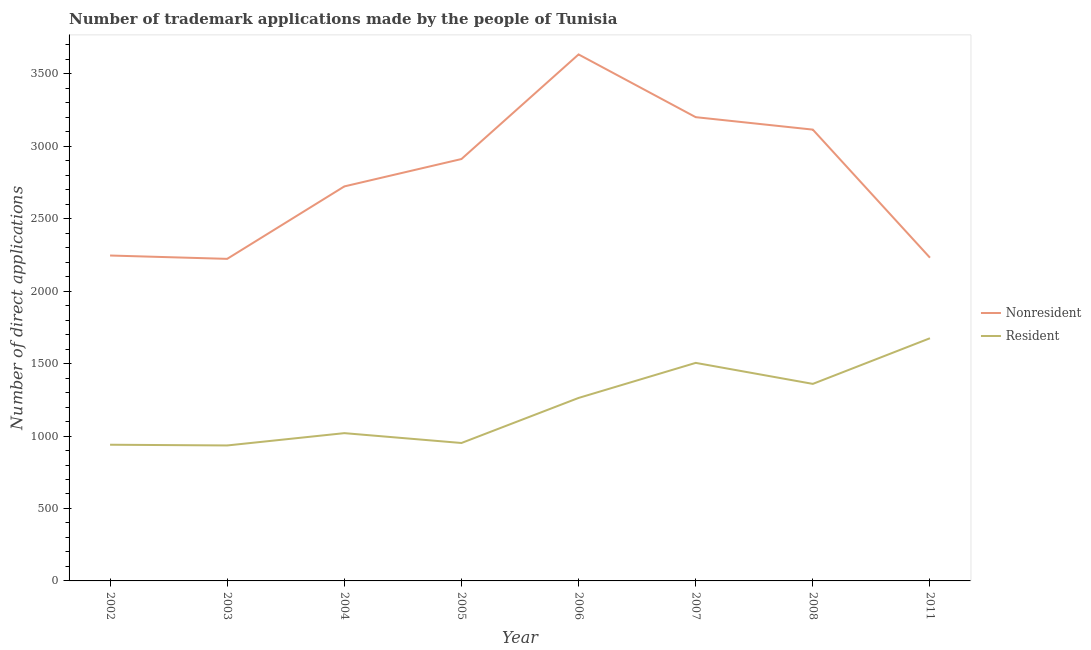Does the line corresponding to number of trademark applications made by residents intersect with the line corresponding to number of trademark applications made by non residents?
Ensure brevity in your answer.  No. Is the number of lines equal to the number of legend labels?
Offer a very short reply. Yes. What is the number of trademark applications made by residents in 2002?
Give a very brief answer. 940. Across all years, what is the maximum number of trademark applications made by non residents?
Provide a short and direct response. 3634. Across all years, what is the minimum number of trademark applications made by non residents?
Ensure brevity in your answer.  2223. What is the total number of trademark applications made by residents in the graph?
Offer a terse response. 9650. What is the difference between the number of trademark applications made by residents in 2003 and that in 2006?
Keep it short and to the point. -328. What is the difference between the number of trademark applications made by non residents in 2004 and the number of trademark applications made by residents in 2005?
Your answer should be very brief. 1771. What is the average number of trademark applications made by non residents per year?
Make the answer very short. 2785.62. In the year 2004, what is the difference between the number of trademark applications made by residents and number of trademark applications made by non residents?
Make the answer very short. -1703. What is the ratio of the number of trademark applications made by non residents in 2003 to that in 2006?
Provide a succinct answer. 0.61. Is the number of trademark applications made by non residents in 2004 less than that in 2005?
Offer a very short reply. Yes. Is the difference between the number of trademark applications made by residents in 2002 and 2003 greater than the difference between the number of trademark applications made by non residents in 2002 and 2003?
Keep it short and to the point. No. What is the difference between the highest and the second highest number of trademark applications made by non residents?
Your response must be concise. 433. What is the difference between the highest and the lowest number of trademark applications made by residents?
Your answer should be very brief. 740. Does the number of trademark applications made by residents monotonically increase over the years?
Offer a very short reply. No. Is the number of trademark applications made by non residents strictly less than the number of trademark applications made by residents over the years?
Provide a short and direct response. No. What is the difference between two consecutive major ticks on the Y-axis?
Offer a very short reply. 500. Are the values on the major ticks of Y-axis written in scientific E-notation?
Keep it short and to the point. No. Does the graph contain grids?
Your response must be concise. No. Where does the legend appear in the graph?
Ensure brevity in your answer.  Center right. How many legend labels are there?
Your answer should be very brief. 2. What is the title of the graph?
Provide a short and direct response. Number of trademark applications made by the people of Tunisia. Does "Rural Population" appear as one of the legend labels in the graph?
Give a very brief answer. No. What is the label or title of the Y-axis?
Keep it short and to the point. Number of direct applications. What is the Number of direct applications in Nonresident in 2002?
Ensure brevity in your answer.  2246. What is the Number of direct applications of Resident in 2002?
Give a very brief answer. 940. What is the Number of direct applications in Nonresident in 2003?
Keep it short and to the point. 2223. What is the Number of direct applications in Resident in 2003?
Give a very brief answer. 935. What is the Number of direct applications in Nonresident in 2004?
Keep it short and to the point. 2723. What is the Number of direct applications in Resident in 2004?
Make the answer very short. 1020. What is the Number of direct applications of Nonresident in 2005?
Your response must be concise. 2912. What is the Number of direct applications in Resident in 2005?
Provide a short and direct response. 952. What is the Number of direct applications of Nonresident in 2006?
Ensure brevity in your answer.  3634. What is the Number of direct applications of Resident in 2006?
Keep it short and to the point. 1263. What is the Number of direct applications of Nonresident in 2007?
Ensure brevity in your answer.  3201. What is the Number of direct applications in Resident in 2007?
Offer a very short reply. 1505. What is the Number of direct applications in Nonresident in 2008?
Make the answer very short. 3115. What is the Number of direct applications of Resident in 2008?
Give a very brief answer. 1360. What is the Number of direct applications of Nonresident in 2011?
Make the answer very short. 2231. What is the Number of direct applications of Resident in 2011?
Your answer should be compact. 1675. Across all years, what is the maximum Number of direct applications in Nonresident?
Your answer should be compact. 3634. Across all years, what is the maximum Number of direct applications of Resident?
Your answer should be compact. 1675. Across all years, what is the minimum Number of direct applications in Nonresident?
Make the answer very short. 2223. Across all years, what is the minimum Number of direct applications of Resident?
Ensure brevity in your answer.  935. What is the total Number of direct applications of Nonresident in the graph?
Provide a short and direct response. 2.23e+04. What is the total Number of direct applications of Resident in the graph?
Provide a succinct answer. 9650. What is the difference between the Number of direct applications in Nonresident in 2002 and that in 2003?
Make the answer very short. 23. What is the difference between the Number of direct applications of Resident in 2002 and that in 2003?
Provide a short and direct response. 5. What is the difference between the Number of direct applications in Nonresident in 2002 and that in 2004?
Provide a short and direct response. -477. What is the difference between the Number of direct applications in Resident in 2002 and that in 2004?
Offer a very short reply. -80. What is the difference between the Number of direct applications in Nonresident in 2002 and that in 2005?
Give a very brief answer. -666. What is the difference between the Number of direct applications of Nonresident in 2002 and that in 2006?
Provide a succinct answer. -1388. What is the difference between the Number of direct applications of Resident in 2002 and that in 2006?
Keep it short and to the point. -323. What is the difference between the Number of direct applications of Nonresident in 2002 and that in 2007?
Keep it short and to the point. -955. What is the difference between the Number of direct applications in Resident in 2002 and that in 2007?
Offer a terse response. -565. What is the difference between the Number of direct applications of Nonresident in 2002 and that in 2008?
Your answer should be very brief. -869. What is the difference between the Number of direct applications in Resident in 2002 and that in 2008?
Your answer should be compact. -420. What is the difference between the Number of direct applications of Resident in 2002 and that in 2011?
Make the answer very short. -735. What is the difference between the Number of direct applications in Nonresident in 2003 and that in 2004?
Provide a short and direct response. -500. What is the difference between the Number of direct applications in Resident in 2003 and that in 2004?
Your answer should be compact. -85. What is the difference between the Number of direct applications of Nonresident in 2003 and that in 2005?
Keep it short and to the point. -689. What is the difference between the Number of direct applications of Resident in 2003 and that in 2005?
Provide a succinct answer. -17. What is the difference between the Number of direct applications in Nonresident in 2003 and that in 2006?
Provide a short and direct response. -1411. What is the difference between the Number of direct applications of Resident in 2003 and that in 2006?
Ensure brevity in your answer.  -328. What is the difference between the Number of direct applications of Nonresident in 2003 and that in 2007?
Ensure brevity in your answer.  -978. What is the difference between the Number of direct applications of Resident in 2003 and that in 2007?
Make the answer very short. -570. What is the difference between the Number of direct applications of Nonresident in 2003 and that in 2008?
Make the answer very short. -892. What is the difference between the Number of direct applications of Resident in 2003 and that in 2008?
Your response must be concise. -425. What is the difference between the Number of direct applications of Resident in 2003 and that in 2011?
Give a very brief answer. -740. What is the difference between the Number of direct applications in Nonresident in 2004 and that in 2005?
Give a very brief answer. -189. What is the difference between the Number of direct applications in Resident in 2004 and that in 2005?
Your response must be concise. 68. What is the difference between the Number of direct applications of Nonresident in 2004 and that in 2006?
Your answer should be very brief. -911. What is the difference between the Number of direct applications of Resident in 2004 and that in 2006?
Offer a very short reply. -243. What is the difference between the Number of direct applications of Nonresident in 2004 and that in 2007?
Your answer should be compact. -478. What is the difference between the Number of direct applications of Resident in 2004 and that in 2007?
Your answer should be very brief. -485. What is the difference between the Number of direct applications in Nonresident in 2004 and that in 2008?
Keep it short and to the point. -392. What is the difference between the Number of direct applications of Resident in 2004 and that in 2008?
Offer a terse response. -340. What is the difference between the Number of direct applications in Nonresident in 2004 and that in 2011?
Give a very brief answer. 492. What is the difference between the Number of direct applications of Resident in 2004 and that in 2011?
Make the answer very short. -655. What is the difference between the Number of direct applications of Nonresident in 2005 and that in 2006?
Provide a short and direct response. -722. What is the difference between the Number of direct applications in Resident in 2005 and that in 2006?
Provide a succinct answer. -311. What is the difference between the Number of direct applications in Nonresident in 2005 and that in 2007?
Make the answer very short. -289. What is the difference between the Number of direct applications of Resident in 2005 and that in 2007?
Offer a terse response. -553. What is the difference between the Number of direct applications of Nonresident in 2005 and that in 2008?
Provide a short and direct response. -203. What is the difference between the Number of direct applications in Resident in 2005 and that in 2008?
Your response must be concise. -408. What is the difference between the Number of direct applications in Nonresident in 2005 and that in 2011?
Your response must be concise. 681. What is the difference between the Number of direct applications of Resident in 2005 and that in 2011?
Offer a terse response. -723. What is the difference between the Number of direct applications of Nonresident in 2006 and that in 2007?
Your answer should be compact. 433. What is the difference between the Number of direct applications in Resident in 2006 and that in 2007?
Offer a very short reply. -242. What is the difference between the Number of direct applications of Nonresident in 2006 and that in 2008?
Your answer should be compact. 519. What is the difference between the Number of direct applications in Resident in 2006 and that in 2008?
Make the answer very short. -97. What is the difference between the Number of direct applications of Nonresident in 2006 and that in 2011?
Your answer should be compact. 1403. What is the difference between the Number of direct applications in Resident in 2006 and that in 2011?
Keep it short and to the point. -412. What is the difference between the Number of direct applications of Nonresident in 2007 and that in 2008?
Make the answer very short. 86. What is the difference between the Number of direct applications of Resident in 2007 and that in 2008?
Your answer should be very brief. 145. What is the difference between the Number of direct applications in Nonresident in 2007 and that in 2011?
Make the answer very short. 970. What is the difference between the Number of direct applications of Resident in 2007 and that in 2011?
Keep it short and to the point. -170. What is the difference between the Number of direct applications in Nonresident in 2008 and that in 2011?
Offer a terse response. 884. What is the difference between the Number of direct applications in Resident in 2008 and that in 2011?
Your answer should be compact. -315. What is the difference between the Number of direct applications in Nonresident in 2002 and the Number of direct applications in Resident in 2003?
Your response must be concise. 1311. What is the difference between the Number of direct applications in Nonresident in 2002 and the Number of direct applications in Resident in 2004?
Offer a terse response. 1226. What is the difference between the Number of direct applications of Nonresident in 2002 and the Number of direct applications of Resident in 2005?
Ensure brevity in your answer.  1294. What is the difference between the Number of direct applications in Nonresident in 2002 and the Number of direct applications in Resident in 2006?
Give a very brief answer. 983. What is the difference between the Number of direct applications of Nonresident in 2002 and the Number of direct applications of Resident in 2007?
Your answer should be compact. 741. What is the difference between the Number of direct applications of Nonresident in 2002 and the Number of direct applications of Resident in 2008?
Provide a succinct answer. 886. What is the difference between the Number of direct applications of Nonresident in 2002 and the Number of direct applications of Resident in 2011?
Your answer should be very brief. 571. What is the difference between the Number of direct applications of Nonresident in 2003 and the Number of direct applications of Resident in 2004?
Give a very brief answer. 1203. What is the difference between the Number of direct applications in Nonresident in 2003 and the Number of direct applications in Resident in 2005?
Provide a succinct answer. 1271. What is the difference between the Number of direct applications in Nonresident in 2003 and the Number of direct applications in Resident in 2006?
Your answer should be compact. 960. What is the difference between the Number of direct applications of Nonresident in 2003 and the Number of direct applications of Resident in 2007?
Make the answer very short. 718. What is the difference between the Number of direct applications in Nonresident in 2003 and the Number of direct applications in Resident in 2008?
Offer a terse response. 863. What is the difference between the Number of direct applications in Nonresident in 2003 and the Number of direct applications in Resident in 2011?
Offer a terse response. 548. What is the difference between the Number of direct applications in Nonresident in 2004 and the Number of direct applications in Resident in 2005?
Offer a terse response. 1771. What is the difference between the Number of direct applications of Nonresident in 2004 and the Number of direct applications of Resident in 2006?
Your answer should be very brief. 1460. What is the difference between the Number of direct applications in Nonresident in 2004 and the Number of direct applications in Resident in 2007?
Ensure brevity in your answer.  1218. What is the difference between the Number of direct applications in Nonresident in 2004 and the Number of direct applications in Resident in 2008?
Your response must be concise. 1363. What is the difference between the Number of direct applications in Nonresident in 2004 and the Number of direct applications in Resident in 2011?
Provide a succinct answer. 1048. What is the difference between the Number of direct applications in Nonresident in 2005 and the Number of direct applications in Resident in 2006?
Provide a short and direct response. 1649. What is the difference between the Number of direct applications in Nonresident in 2005 and the Number of direct applications in Resident in 2007?
Your response must be concise. 1407. What is the difference between the Number of direct applications of Nonresident in 2005 and the Number of direct applications of Resident in 2008?
Give a very brief answer. 1552. What is the difference between the Number of direct applications of Nonresident in 2005 and the Number of direct applications of Resident in 2011?
Offer a very short reply. 1237. What is the difference between the Number of direct applications in Nonresident in 2006 and the Number of direct applications in Resident in 2007?
Offer a very short reply. 2129. What is the difference between the Number of direct applications of Nonresident in 2006 and the Number of direct applications of Resident in 2008?
Offer a very short reply. 2274. What is the difference between the Number of direct applications in Nonresident in 2006 and the Number of direct applications in Resident in 2011?
Your answer should be very brief. 1959. What is the difference between the Number of direct applications of Nonresident in 2007 and the Number of direct applications of Resident in 2008?
Make the answer very short. 1841. What is the difference between the Number of direct applications in Nonresident in 2007 and the Number of direct applications in Resident in 2011?
Your answer should be very brief. 1526. What is the difference between the Number of direct applications of Nonresident in 2008 and the Number of direct applications of Resident in 2011?
Your response must be concise. 1440. What is the average Number of direct applications of Nonresident per year?
Provide a succinct answer. 2785.62. What is the average Number of direct applications in Resident per year?
Your answer should be compact. 1206.25. In the year 2002, what is the difference between the Number of direct applications in Nonresident and Number of direct applications in Resident?
Offer a terse response. 1306. In the year 2003, what is the difference between the Number of direct applications of Nonresident and Number of direct applications of Resident?
Provide a short and direct response. 1288. In the year 2004, what is the difference between the Number of direct applications in Nonresident and Number of direct applications in Resident?
Give a very brief answer. 1703. In the year 2005, what is the difference between the Number of direct applications in Nonresident and Number of direct applications in Resident?
Ensure brevity in your answer.  1960. In the year 2006, what is the difference between the Number of direct applications in Nonresident and Number of direct applications in Resident?
Offer a terse response. 2371. In the year 2007, what is the difference between the Number of direct applications of Nonresident and Number of direct applications of Resident?
Keep it short and to the point. 1696. In the year 2008, what is the difference between the Number of direct applications of Nonresident and Number of direct applications of Resident?
Keep it short and to the point. 1755. In the year 2011, what is the difference between the Number of direct applications in Nonresident and Number of direct applications in Resident?
Provide a succinct answer. 556. What is the ratio of the Number of direct applications of Nonresident in 2002 to that in 2003?
Provide a short and direct response. 1.01. What is the ratio of the Number of direct applications of Resident in 2002 to that in 2003?
Make the answer very short. 1.01. What is the ratio of the Number of direct applications in Nonresident in 2002 to that in 2004?
Give a very brief answer. 0.82. What is the ratio of the Number of direct applications of Resident in 2002 to that in 2004?
Your answer should be very brief. 0.92. What is the ratio of the Number of direct applications of Nonresident in 2002 to that in 2005?
Your answer should be compact. 0.77. What is the ratio of the Number of direct applications of Resident in 2002 to that in 2005?
Your answer should be compact. 0.99. What is the ratio of the Number of direct applications in Nonresident in 2002 to that in 2006?
Make the answer very short. 0.62. What is the ratio of the Number of direct applications in Resident in 2002 to that in 2006?
Offer a very short reply. 0.74. What is the ratio of the Number of direct applications of Nonresident in 2002 to that in 2007?
Provide a succinct answer. 0.7. What is the ratio of the Number of direct applications of Resident in 2002 to that in 2007?
Ensure brevity in your answer.  0.62. What is the ratio of the Number of direct applications in Nonresident in 2002 to that in 2008?
Keep it short and to the point. 0.72. What is the ratio of the Number of direct applications of Resident in 2002 to that in 2008?
Your answer should be compact. 0.69. What is the ratio of the Number of direct applications in Nonresident in 2002 to that in 2011?
Ensure brevity in your answer.  1.01. What is the ratio of the Number of direct applications in Resident in 2002 to that in 2011?
Make the answer very short. 0.56. What is the ratio of the Number of direct applications of Nonresident in 2003 to that in 2004?
Offer a very short reply. 0.82. What is the ratio of the Number of direct applications of Resident in 2003 to that in 2004?
Make the answer very short. 0.92. What is the ratio of the Number of direct applications in Nonresident in 2003 to that in 2005?
Provide a short and direct response. 0.76. What is the ratio of the Number of direct applications of Resident in 2003 to that in 2005?
Make the answer very short. 0.98. What is the ratio of the Number of direct applications of Nonresident in 2003 to that in 2006?
Provide a succinct answer. 0.61. What is the ratio of the Number of direct applications in Resident in 2003 to that in 2006?
Provide a short and direct response. 0.74. What is the ratio of the Number of direct applications of Nonresident in 2003 to that in 2007?
Offer a terse response. 0.69. What is the ratio of the Number of direct applications of Resident in 2003 to that in 2007?
Your answer should be compact. 0.62. What is the ratio of the Number of direct applications in Nonresident in 2003 to that in 2008?
Provide a succinct answer. 0.71. What is the ratio of the Number of direct applications of Resident in 2003 to that in 2008?
Keep it short and to the point. 0.69. What is the ratio of the Number of direct applications in Resident in 2003 to that in 2011?
Keep it short and to the point. 0.56. What is the ratio of the Number of direct applications in Nonresident in 2004 to that in 2005?
Provide a succinct answer. 0.94. What is the ratio of the Number of direct applications in Resident in 2004 to that in 2005?
Your answer should be very brief. 1.07. What is the ratio of the Number of direct applications of Nonresident in 2004 to that in 2006?
Offer a very short reply. 0.75. What is the ratio of the Number of direct applications of Resident in 2004 to that in 2006?
Offer a terse response. 0.81. What is the ratio of the Number of direct applications of Nonresident in 2004 to that in 2007?
Provide a succinct answer. 0.85. What is the ratio of the Number of direct applications in Resident in 2004 to that in 2007?
Keep it short and to the point. 0.68. What is the ratio of the Number of direct applications in Nonresident in 2004 to that in 2008?
Provide a short and direct response. 0.87. What is the ratio of the Number of direct applications of Resident in 2004 to that in 2008?
Your response must be concise. 0.75. What is the ratio of the Number of direct applications in Nonresident in 2004 to that in 2011?
Your answer should be compact. 1.22. What is the ratio of the Number of direct applications of Resident in 2004 to that in 2011?
Give a very brief answer. 0.61. What is the ratio of the Number of direct applications in Nonresident in 2005 to that in 2006?
Ensure brevity in your answer.  0.8. What is the ratio of the Number of direct applications of Resident in 2005 to that in 2006?
Make the answer very short. 0.75. What is the ratio of the Number of direct applications in Nonresident in 2005 to that in 2007?
Offer a very short reply. 0.91. What is the ratio of the Number of direct applications in Resident in 2005 to that in 2007?
Keep it short and to the point. 0.63. What is the ratio of the Number of direct applications of Nonresident in 2005 to that in 2008?
Your response must be concise. 0.93. What is the ratio of the Number of direct applications in Nonresident in 2005 to that in 2011?
Provide a short and direct response. 1.31. What is the ratio of the Number of direct applications of Resident in 2005 to that in 2011?
Offer a very short reply. 0.57. What is the ratio of the Number of direct applications in Nonresident in 2006 to that in 2007?
Make the answer very short. 1.14. What is the ratio of the Number of direct applications in Resident in 2006 to that in 2007?
Your response must be concise. 0.84. What is the ratio of the Number of direct applications of Nonresident in 2006 to that in 2008?
Your answer should be compact. 1.17. What is the ratio of the Number of direct applications of Resident in 2006 to that in 2008?
Keep it short and to the point. 0.93. What is the ratio of the Number of direct applications in Nonresident in 2006 to that in 2011?
Your answer should be compact. 1.63. What is the ratio of the Number of direct applications in Resident in 2006 to that in 2011?
Ensure brevity in your answer.  0.75. What is the ratio of the Number of direct applications in Nonresident in 2007 to that in 2008?
Offer a very short reply. 1.03. What is the ratio of the Number of direct applications in Resident in 2007 to that in 2008?
Provide a succinct answer. 1.11. What is the ratio of the Number of direct applications of Nonresident in 2007 to that in 2011?
Offer a very short reply. 1.43. What is the ratio of the Number of direct applications of Resident in 2007 to that in 2011?
Offer a very short reply. 0.9. What is the ratio of the Number of direct applications in Nonresident in 2008 to that in 2011?
Offer a very short reply. 1.4. What is the ratio of the Number of direct applications of Resident in 2008 to that in 2011?
Your answer should be compact. 0.81. What is the difference between the highest and the second highest Number of direct applications in Nonresident?
Offer a terse response. 433. What is the difference between the highest and the second highest Number of direct applications in Resident?
Offer a terse response. 170. What is the difference between the highest and the lowest Number of direct applications of Nonresident?
Provide a succinct answer. 1411. What is the difference between the highest and the lowest Number of direct applications in Resident?
Provide a succinct answer. 740. 